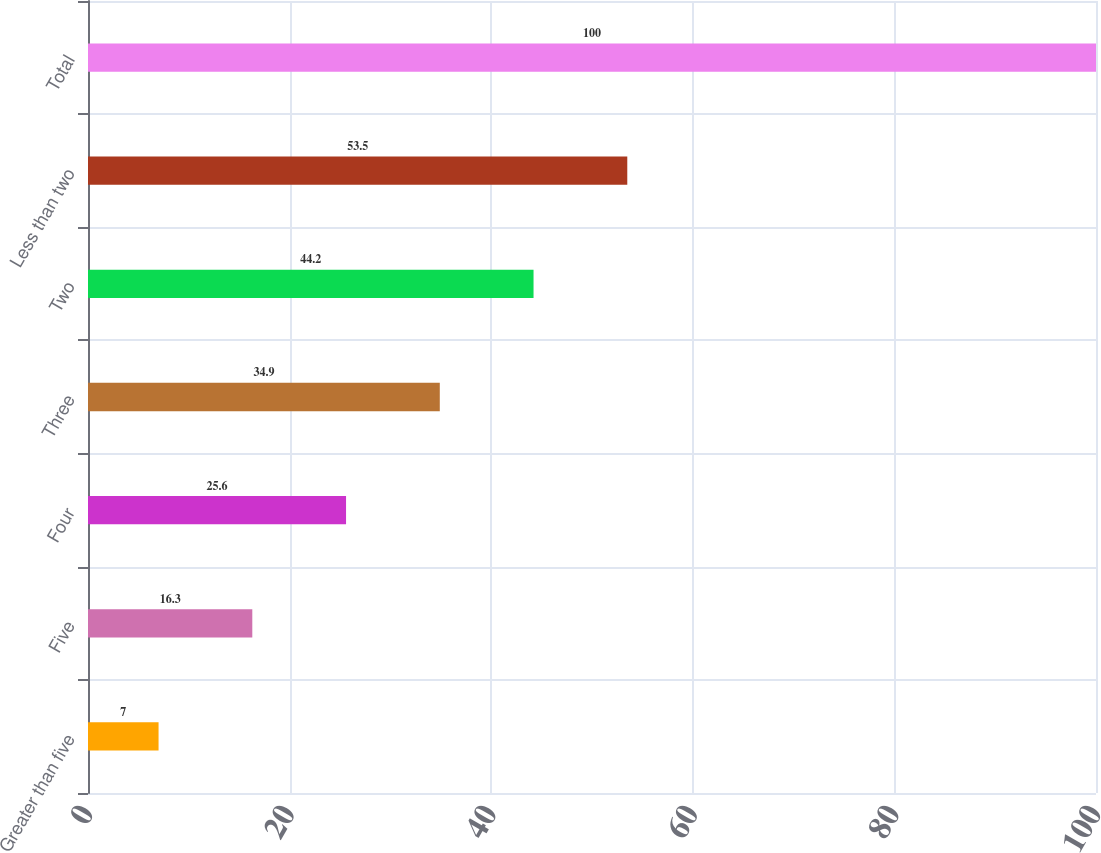<chart> <loc_0><loc_0><loc_500><loc_500><bar_chart><fcel>Greater than five<fcel>Five<fcel>Four<fcel>Three<fcel>Two<fcel>Less than two<fcel>Total<nl><fcel>7<fcel>16.3<fcel>25.6<fcel>34.9<fcel>44.2<fcel>53.5<fcel>100<nl></chart> 